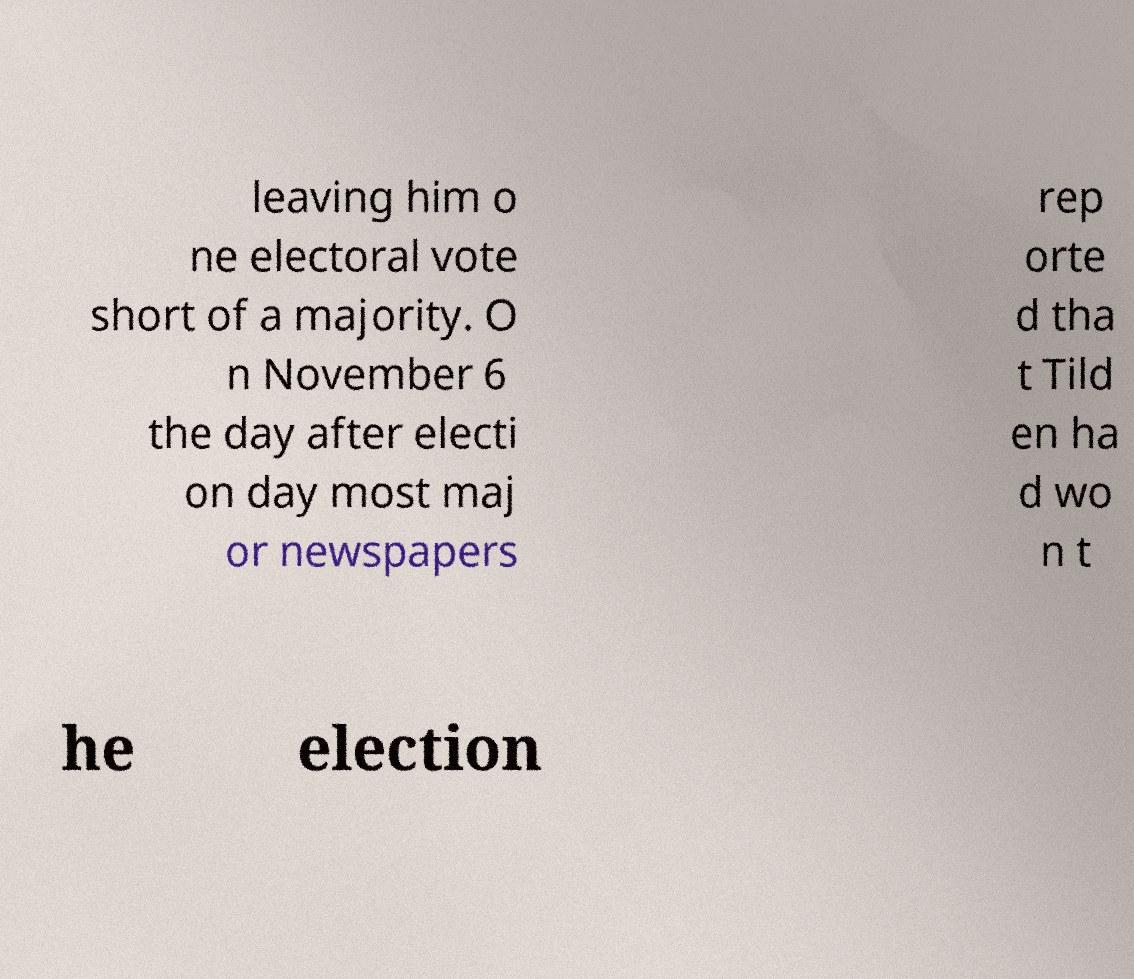Please read and relay the text visible in this image. What does it say? leaving him o ne electoral vote short of a majority. O n November 6 the day after electi on day most maj or newspapers rep orte d tha t Tild en ha d wo n t he election 